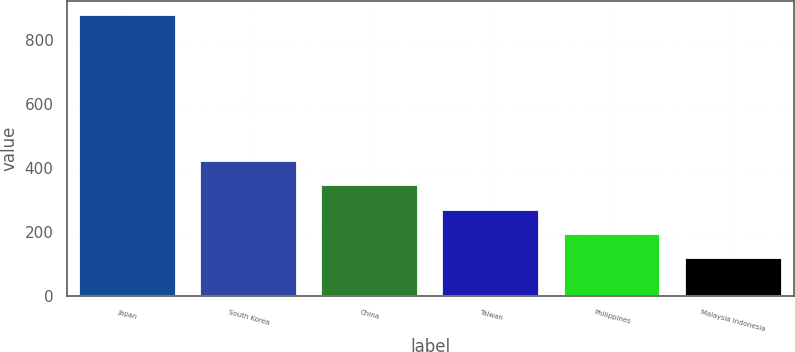Convert chart to OTSL. <chart><loc_0><loc_0><loc_500><loc_500><bar_chart><fcel>Japan<fcel>South Korea<fcel>China<fcel>Taiwan<fcel>Philippines<fcel>Malaysia Indonesia<nl><fcel>875<fcel>420.8<fcel>345.1<fcel>269.4<fcel>193.7<fcel>118<nl></chart> 